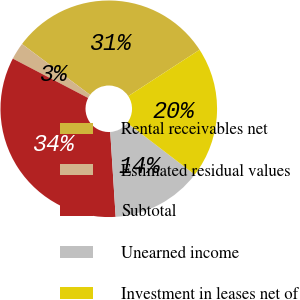Convert chart. <chart><loc_0><loc_0><loc_500><loc_500><pie_chart><fcel>Rental receivables net<fcel>Estimated residual values<fcel>Subtotal<fcel>Unearned income<fcel>Investment in leases net of<nl><fcel>30.62%<fcel>2.54%<fcel>33.68%<fcel>13.58%<fcel>19.58%<nl></chart> 